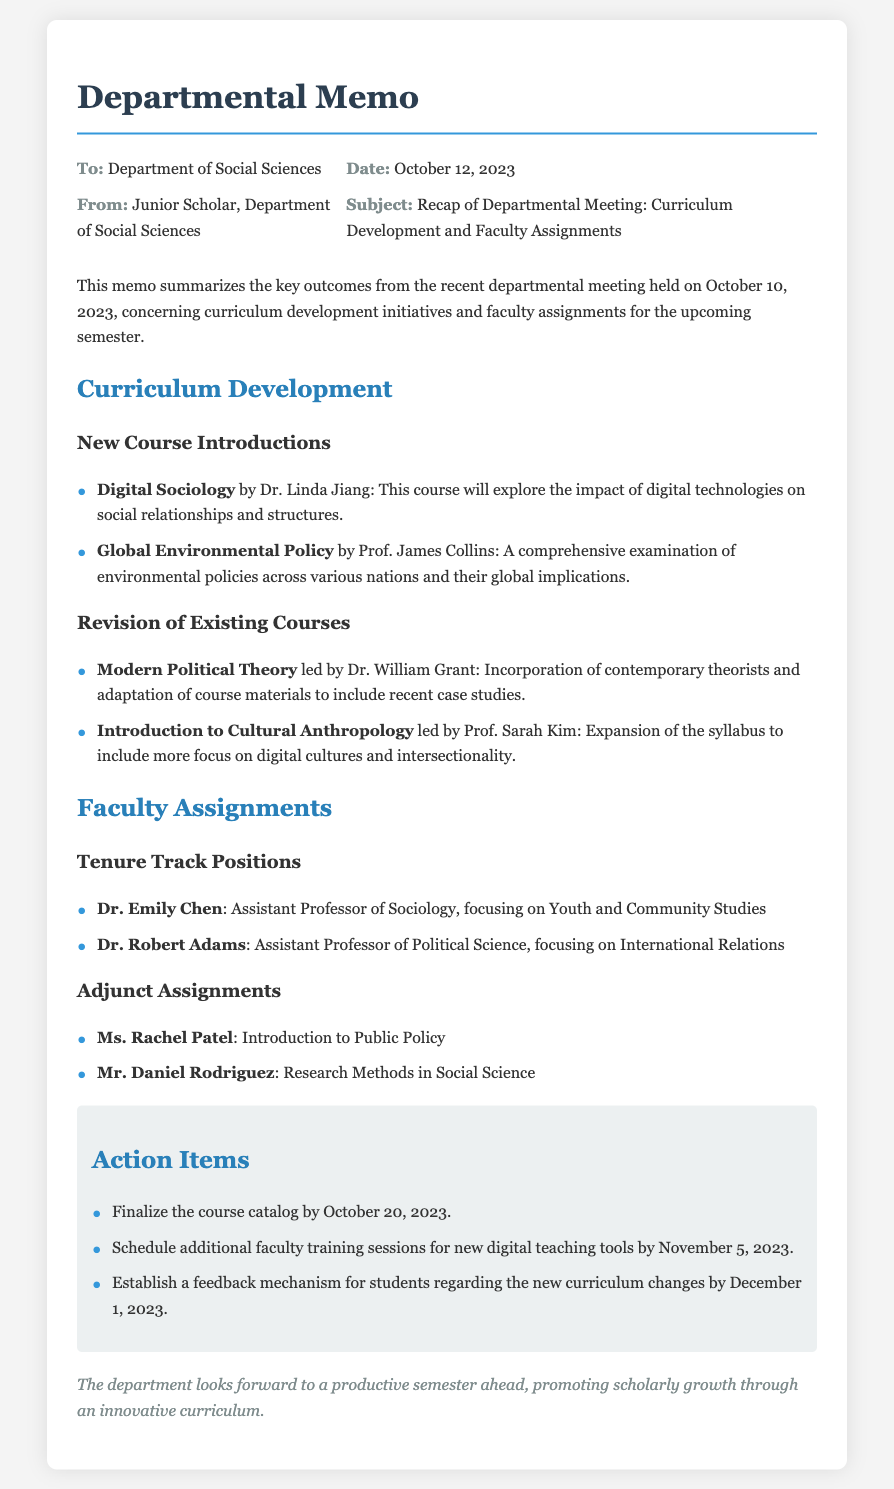What new course is being introduced by Dr. Linda Jiang? Dr. Linda Jiang's new course is titled Digital Sociology, which explores the impact of digital technologies on social relationships and structures.
Answer: Digital Sociology Who is assigned to teach Introduction to Public Policy? The document states that Ms. Rachel Patel is assigned to teach Introduction to Public Policy.
Answer: Ms. Rachel Patel What is the deadline to finalize the course catalog? The memo specifically mentions the deadline to finalize the course catalog by October 20, 2023.
Answer: October 20, 2023 Which course's syllabus will include a focus on digital cultures? According to the document, the syllabus for Introduction to Cultural Anthropology will include more focus on digital cultures and intersectionality.
Answer: Introduction to Cultural Anthropology How many tenure track positions are mentioned in the memo? The memo lists a total of two tenure track positions: Dr. Emily Chen and Dr. Robert Adams.
Answer: 2 What is the focus area of Dr. Robert Adams? Dr. Robert Adams is focusing on International Relations as part of his tenure track position.
Answer: International Relations When is the feedback mechanism for students regarding the new curriculum supposed to be established? The document specifies that the feedback mechanism should be established by December 1, 2023.
Answer: December 1, 2023 Who led the revision of Modern Political Theory? The revision of Modern Political Theory was led by Dr. William Grant.
Answer: Dr. William Grant What is the subject of Prof. James Collins' new course? The subject of Prof. James Collins' new course is Global Environmental Policy.
Answer: Global Environmental Policy 